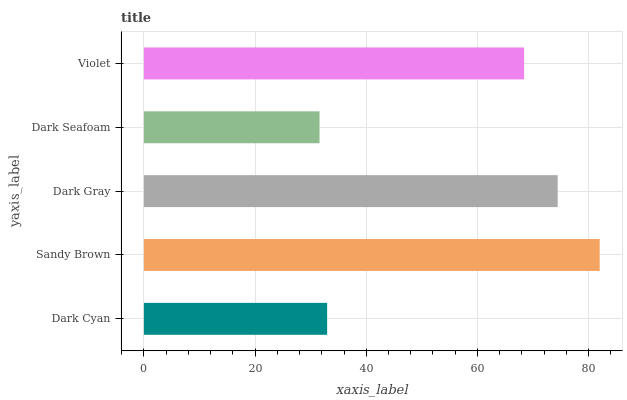Is Dark Seafoam the minimum?
Answer yes or no. Yes. Is Sandy Brown the maximum?
Answer yes or no. Yes. Is Dark Gray the minimum?
Answer yes or no. No. Is Dark Gray the maximum?
Answer yes or no. No. Is Sandy Brown greater than Dark Gray?
Answer yes or no. Yes. Is Dark Gray less than Sandy Brown?
Answer yes or no. Yes. Is Dark Gray greater than Sandy Brown?
Answer yes or no. No. Is Sandy Brown less than Dark Gray?
Answer yes or no. No. Is Violet the high median?
Answer yes or no. Yes. Is Violet the low median?
Answer yes or no. Yes. Is Sandy Brown the high median?
Answer yes or no. No. Is Sandy Brown the low median?
Answer yes or no. No. 